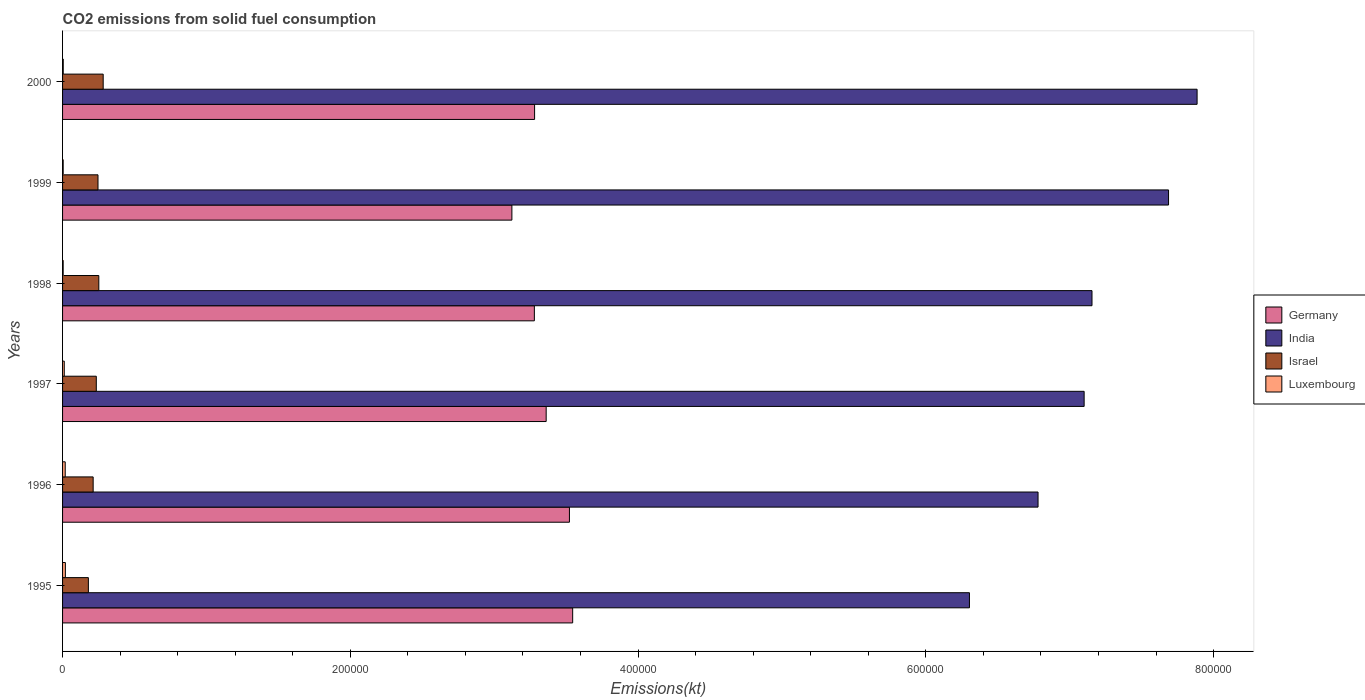How many different coloured bars are there?
Your response must be concise. 4. How many groups of bars are there?
Your answer should be compact. 6. Are the number of bars per tick equal to the number of legend labels?
Provide a succinct answer. Yes. What is the amount of CO2 emitted in India in 1996?
Provide a succinct answer. 6.78e+05. Across all years, what is the maximum amount of CO2 emitted in Luxembourg?
Your answer should be very brief. 1947.18. Across all years, what is the minimum amount of CO2 emitted in India?
Ensure brevity in your answer.  6.30e+05. In which year was the amount of CO2 emitted in India maximum?
Offer a terse response. 2000. In which year was the amount of CO2 emitted in Germany minimum?
Your response must be concise. 1999. What is the total amount of CO2 emitted in Germany in the graph?
Provide a succinct answer. 2.01e+06. What is the difference between the amount of CO2 emitted in Germany in 1995 and that in 1998?
Offer a terse response. 2.66e+04. What is the difference between the amount of CO2 emitted in Luxembourg in 2000 and the amount of CO2 emitted in Germany in 1995?
Your answer should be compact. -3.54e+05. What is the average amount of CO2 emitted in Germany per year?
Keep it short and to the point. 3.35e+05. In the year 1995, what is the difference between the amount of CO2 emitted in India and amount of CO2 emitted in Luxembourg?
Your answer should be very brief. 6.28e+05. In how many years, is the amount of CO2 emitted in India greater than 40000 kt?
Ensure brevity in your answer.  6. What is the ratio of the amount of CO2 emitted in Israel in 1996 to that in 2000?
Offer a very short reply. 0.75. Is the amount of CO2 emitted in Germany in 1999 less than that in 2000?
Your answer should be compact. Yes. Is the difference between the amount of CO2 emitted in India in 1997 and 1998 greater than the difference between the amount of CO2 emitted in Luxembourg in 1997 and 1998?
Provide a short and direct response. No. What is the difference between the highest and the second highest amount of CO2 emitted in India?
Ensure brevity in your answer.  1.98e+04. What is the difference between the highest and the lowest amount of CO2 emitted in Israel?
Provide a succinct answer. 1.03e+04. In how many years, is the amount of CO2 emitted in Luxembourg greater than the average amount of CO2 emitted in Luxembourg taken over all years?
Offer a very short reply. 3. Is it the case that in every year, the sum of the amount of CO2 emitted in Israel and amount of CO2 emitted in India is greater than the sum of amount of CO2 emitted in Luxembourg and amount of CO2 emitted in Germany?
Your answer should be very brief. Yes. What does the 3rd bar from the top in 1995 represents?
Ensure brevity in your answer.  India. Are all the bars in the graph horizontal?
Your response must be concise. Yes. How many years are there in the graph?
Keep it short and to the point. 6. What is the difference between two consecutive major ticks on the X-axis?
Provide a succinct answer. 2.00e+05. Does the graph contain any zero values?
Your answer should be very brief. No. Does the graph contain grids?
Ensure brevity in your answer.  No. How many legend labels are there?
Give a very brief answer. 4. What is the title of the graph?
Keep it short and to the point. CO2 emissions from solid fuel consumption. Does "Georgia" appear as one of the legend labels in the graph?
Your answer should be compact. No. What is the label or title of the X-axis?
Keep it short and to the point. Emissions(kt). What is the label or title of the Y-axis?
Your response must be concise. Years. What is the Emissions(kt) of Germany in 1995?
Your response must be concise. 3.55e+05. What is the Emissions(kt) in India in 1995?
Your response must be concise. 6.30e+05. What is the Emissions(kt) of Israel in 1995?
Make the answer very short. 1.79e+04. What is the Emissions(kt) in Luxembourg in 1995?
Make the answer very short. 1947.18. What is the Emissions(kt) in Germany in 1996?
Provide a short and direct response. 3.52e+05. What is the Emissions(kt) in India in 1996?
Your answer should be very brief. 6.78e+05. What is the Emissions(kt) of Israel in 1996?
Give a very brief answer. 2.13e+04. What is the Emissions(kt) of Luxembourg in 1996?
Offer a terse response. 1840.83. What is the Emissions(kt) of Germany in 1997?
Your response must be concise. 3.36e+05. What is the Emissions(kt) of India in 1997?
Your answer should be compact. 7.10e+05. What is the Emissions(kt) of Israel in 1997?
Ensure brevity in your answer.  2.34e+04. What is the Emissions(kt) of Luxembourg in 1997?
Offer a very short reply. 1184.44. What is the Emissions(kt) of Germany in 1998?
Offer a terse response. 3.28e+05. What is the Emissions(kt) in India in 1998?
Provide a succinct answer. 7.15e+05. What is the Emissions(kt) of Israel in 1998?
Your answer should be compact. 2.52e+04. What is the Emissions(kt) in Luxembourg in 1998?
Provide a short and direct response. 425.37. What is the Emissions(kt) of Germany in 1999?
Provide a succinct answer. 3.12e+05. What is the Emissions(kt) of India in 1999?
Keep it short and to the point. 7.69e+05. What is the Emissions(kt) of Israel in 1999?
Your answer should be very brief. 2.46e+04. What is the Emissions(kt) of Luxembourg in 1999?
Keep it short and to the point. 429.04. What is the Emissions(kt) in Germany in 2000?
Ensure brevity in your answer.  3.28e+05. What is the Emissions(kt) of India in 2000?
Your answer should be compact. 7.89e+05. What is the Emissions(kt) of Israel in 2000?
Your response must be concise. 2.82e+04. What is the Emissions(kt) of Luxembourg in 2000?
Offer a very short reply. 476.71. Across all years, what is the maximum Emissions(kt) of Germany?
Your answer should be very brief. 3.55e+05. Across all years, what is the maximum Emissions(kt) of India?
Offer a terse response. 7.89e+05. Across all years, what is the maximum Emissions(kt) in Israel?
Your answer should be very brief. 2.82e+04. Across all years, what is the maximum Emissions(kt) of Luxembourg?
Keep it short and to the point. 1947.18. Across all years, what is the minimum Emissions(kt) in Germany?
Give a very brief answer. 3.12e+05. Across all years, what is the minimum Emissions(kt) of India?
Offer a very short reply. 6.30e+05. Across all years, what is the minimum Emissions(kt) of Israel?
Your answer should be compact. 1.79e+04. Across all years, what is the minimum Emissions(kt) of Luxembourg?
Ensure brevity in your answer.  425.37. What is the total Emissions(kt) in Germany in the graph?
Give a very brief answer. 2.01e+06. What is the total Emissions(kt) in India in the graph?
Offer a very short reply. 4.29e+06. What is the total Emissions(kt) in Israel in the graph?
Provide a short and direct response. 1.41e+05. What is the total Emissions(kt) in Luxembourg in the graph?
Your answer should be very brief. 6303.57. What is the difference between the Emissions(kt) of Germany in 1995 and that in 1996?
Your response must be concise. 2244.2. What is the difference between the Emissions(kt) of India in 1995 and that in 1996?
Provide a short and direct response. -4.77e+04. What is the difference between the Emissions(kt) of Israel in 1995 and that in 1996?
Give a very brief answer. -3322.3. What is the difference between the Emissions(kt) in Luxembourg in 1995 and that in 1996?
Offer a very short reply. 106.34. What is the difference between the Emissions(kt) of Germany in 1995 and that in 1997?
Provide a short and direct response. 1.84e+04. What is the difference between the Emissions(kt) in India in 1995 and that in 1997?
Provide a short and direct response. -7.97e+04. What is the difference between the Emissions(kt) in Israel in 1995 and that in 1997?
Make the answer very short. -5504.17. What is the difference between the Emissions(kt) of Luxembourg in 1995 and that in 1997?
Ensure brevity in your answer.  762.74. What is the difference between the Emissions(kt) in Germany in 1995 and that in 1998?
Offer a terse response. 2.66e+04. What is the difference between the Emissions(kt) of India in 1995 and that in 1998?
Give a very brief answer. -8.52e+04. What is the difference between the Emissions(kt) of Israel in 1995 and that in 1998?
Ensure brevity in your answer.  -7249.66. What is the difference between the Emissions(kt) of Luxembourg in 1995 and that in 1998?
Provide a succinct answer. 1521.81. What is the difference between the Emissions(kt) in Germany in 1995 and that in 1999?
Ensure brevity in your answer.  4.22e+04. What is the difference between the Emissions(kt) in India in 1995 and that in 1999?
Provide a succinct answer. -1.38e+05. What is the difference between the Emissions(kt) in Israel in 1995 and that in 1999?
Your response must be concise. -6684.94. What is the difference between the Emissions(kt) of Luxembourg in 1995 and that in 1999?
Ensure brevity in your answer.  1518.14. What is the difference between the Emissions(kt) in Germany in 1995 and that in 2000?
Your answer should be compact. 2.65e+04. What is the difference between the Emissions(kt) in India in 1995 and that in 2000?
Your response must be concise. -1.58e+05. What is the difference between the Emissions(kt) in Israel in 1995 and that in 2000?
Your answer should be very brief. -1.03e+04. What is the difference between the Emissions(kt) in Luxembourg in 1995 and that in 2000?
Offer a very short reply. 1470.47. What is the difference between the Emissions(kt) of Germany in 1996 and that in 1997?
Make the answer very short. 1.62e+04. What is the difference between the Emissions(kt) in India in 1996 and that in 1997?
Offer a very short reply. -3.20e+04. What is the difference between the Emissions(kt) in Israel in 1996 and that in 1997?
Give a very brief answer. -2181.86. What is the difference between the Emissions(kt) in Luxembourg in 1996 and that in 1997?
Your answer should be very brief. 656.39. What is the difference between the Emissions(kt) in Germany in 1996 and that in 1998?
Offer a very short reply. 2.44e+04. What is the difference between the Emissions(kt) in India in 1996 and that in 1998?
Provide a succinct answer. -3.75e+04. What is the difference between the Emissions(kt) of Israel in 1996 and that in 1998?
Make the answer very short. -3927.36. What is the difference between the Emissions(kt) in Luxembourg in 1996 and that in 1998?
Provide a short and direct response. 1415.46. What is the difference between the Emissions(kt) of Germany in 1996 and that in 1999?
Ensure brevity in your answer.  4.00e+04. What is the difference between the Emissions(kt) of India in 1996 and that in 1999?
Provide a succinct answer. -9.07e+04. What is the difference between the Emissions(kt) in Israel in 1996 and that in 1999?
Your answer should be compact. -3362.64. What is the difference between the Emissions(kt) of Luxembourg in 1996 and that in 1999?
Give a very brief answer. 1411.8. What is the difference between the Emissions(kt) in Germany in 1996 and that in 2000?
Make the answer very short. 2.42e+04. What is the difference between the Emissions(kt) of India in 1996 and that in 2000?
Your response must be concise. -1.11e+05. What is the difference between the Emissions(kt) of Israel in 1996 and that in 2000?
Provide a succinct answer. -6967.3. What is the difference between the Emissions(kt) in Luxembourg in 1996 and that in 2000?
Keep it short and to the point. 1364.12. What is the difference between the Emissions(kt) in Germany in 1997 and that in 1998?
Your response must be concise. 8206.75. What is the difference between the Emissions(kt) of India in 1997 and that in 1998?
Offer a terse response. -5460.16. What is the difference between the Emissions(kt) of Israel in 1997 and that in 1998?
Your answer should be very brief. -1745.49. What is the difference between the Emissions(kt) of Luxembourg in 1997 and that in 1998?
Your answer should be very brief. 759.07. What is the difference between the Emissions(kt) in Germany in 1997 and that in 1999?
Your response must be concise. 2.38e+04. What is the difference between the Emissions(kt) in India in 1997 and that in 1999?
Your answer should be compact. -5.87e+04. What is the difference between the Emissions(kt) in Israel in 1997 and that in 1999?
Provide a short and direct response. -1180.77. What is the difference between the Emissions(kt) of Luxembourg in 1997 and that in 1999?
Ensure brevity in your answer.  755.4. What is the difference between the Emissions(kt) in Germany in 1997 and that in 2000?
Make the answer very short. 8049.06. What is the difference between the Emissions(kt) of India in 1997 and that in 2000?
Ensure brevity in your answer.  -7.85e+04. What is the difference between the Emissions(kt) of Israel in 1997 and that in 2000?
Provide a succinct answer. -4785.44. What is the difference between the Emissions(kt) in Luxembourg in 1997 and that in 2000?
Your answer should be very brief. 707.73. What is the difference between the Emissions(kt) in Germany in 1998 and that in 1999?
Make the answer very short. 1.56e+04. What is the difference between the Emissions(kt) of India in 1998 and that in 1999?
Ensure brevity in your answer.  -5.32e+04. What is the difference between the Emissions(kt) in Israel in 1998 and that in 1999?
Provide a short and direct response. 564.72. What is the difference between the Emissions(kt) in Luxembourg in 1998 and that in 1999?
Offer a very short reply. -3.67. What is the difference between the Emissions(kt) of Germany in 1998 and that in 2000?
Keep it short and to the point. -157.68. What is the difference between the Emissions(kt) of India in 1998 and that in 2000?
Ensure brevity in your answer.  -7.30e+04. What is the difference between the Emissions(kt) in Israel in 1998 and that in 2000?
Your response must be concise. -3039.94. What is the difference between the Emissions(kt) of Luxembourg in 1998 and that in 2000?
Your response must be concise. -51.34. What is the difference between the Emissions(kt) in Germany in 1999 and that in 2000?
Provide a short and direct response. -1.58e+04. What is the difference between the Emissions(kt) in India in 1999 and that in 2000?
Give a very brief answer. -1.98e+04. What is the difference between the Emissions(kt) of Israel in 1999 and that in 2000?
Make the answer very short. -3604.66. What is the difference between the Emissions(kt) of Luxembourg in 1999 and that in 2000?
Your answer should be compact. -47.67. What is the difference between the Emissions(kt) of Germany in 1995 and the Emissions(kt) of India in 1996?
Your response must be concise. -3.23e+05. What is the difference between the Emissions(kt) in Germany in 1995 and the Emissions(kt) in Israel in 1996?
Provide a short and direct response. 3.33e+05. What is the difference between the Emissions(kt) of Germany in 1995 and the Emissions(kt) of Luxembourg in 1996?
Your answer should be very brief. 3.53e+05. What is the difference between the Emissions(kt) of India in 1995 and the Emissions(kt) of Israel in 1996?
Keep it short and to the point. 6.09e+05. What is the difference between the Emissions(kt) of India in 1995 and the Emissions(kt) of Luxembourg in 1996?
Provide a succinct answer. 6.28e+05. What is the difference between the Emissions(kt) of Israel in 1995 and the Emissions(kt) of Luxembourg in 1996?
Your answer should be compact. 1.61e+04. What is the difference between the Emissions(kt) in Germany in 1995 and the Emissions(kt) in India in 1997?
Provide a short and direct response. -3.55e+05. What is the difference between the Emissions(kt) in Germany in 1995 and the Emissions(kt) in Israel in 1997?
Keep it short and to the point. 3.31e+05. What is the difference between the Emissions(kt) in Germany in 1995 and the Emissions(kt) in Luxembourg in 1997?
Provide a short and direct response. 3.53e+05. What is the difference between the Emissions(kt) of India in 1995 and the Emissions(kt) of Israel in 1997?
Ensure brevity in your answer.  6.07e+05. What is the difference between the Emissions(kt) of India in 1995 and the Emissions(kt) of Luxembourg in 1997?
Ensure brevity in your answer.  6.29e+05. What is the difference between the Emissions(kt) in Israel in 1995 and the Emissions(kt) in Luxembourg in 1997?
Offer a terse response. 1.68e+04. What is the difference between the Emissions(kt) in Germany in 1995 and the Emissions(kt) in India in 1998?
Ensure brevity in your answer.  -3.61e+05. What is the difference between the Emissions(kt) of Germany in 1995 and the Emissions(kt) of Israel in 1998?
Your response must be concise. 3.29e+05. What is the difference between the Emissions(kt) of Germany in 1995 and the Emissions(kt) of Luxembourg in 1998?
Offer a very short reply. 3.54e+05. What is the difference between the Emissions(kt) in India in 1995 and the Emissions(kt) in Israel in 1998?
Your response must be concise. 6.05e+05. What is the difference between the Emissions(kt) in India in 1995 and the Emissions(kt) in Luxembourg in 1998?
Your response must be concise. 6.30e+05. What is the difference between the Emissions(kt) in Israel in 1995 and the Emissions(kt) in Luxembourg in 1998?
Provide a short and direct response. 1.75e+04. What is the difference between the Emissions(kt) of Germany in 1995 and the Emissions(kt) of India in 1999?
Your answer should be very brief. -4.14e+05. What is the difference between the Emissions(kt) of Germany in 1995 and the Emissions(kt) of Israel in 1999?
Provide a succinct answer. 3.30e+05. What is the difference between the Emissions(kt) in Germany in 1995 and the Emissions(kt) in Luxembourg in 1999?
Your answer should be very brief. 3.54e+05. What is the difference between the Emissions(kt) of India in 1995 and the Emissions(kt) of Israel in 1999?
Keep it short and to the point. 6.06e+05. What is the difference between the Emissions(kt) in India in 1995 and the Emissions(kt) in Luxembourg in 1999?
Ensure brevity in your answer.  6.30e+05. What is the difference between the Emissions(kt) in Israel in 1995 and the Emissions(kt) in Luxembourg in 1999?
Provide a succinct answer. 1.75e+04. What is the difference between the Emissions(kt) in Germany in 1995 and the Emissions(kt) in India in 2000?
Keep it short and to the point. -4.34e+05. What is the difference between the Emissions(kt) in Germany in 1995 and the Emissions(kt) in Israel in 2000?
Your response must be concise. 3.26e+05. What is the difference between the Emissions(kt) of Germany in 1995 and the Emissions(kt) of Luxembourg in 2000?
Your answer should be very brief. 3.54e+05. What is the difference between the Emissions(kt) in India in 1995 and the Emissions(kt) in Israel in 2000?
Make the answer very short. 6.02e+05. What is the difference between the Emissions(kt) in India in 1995 and the Emissions(kt) in Luxembourg in 2000?
Offer a terse response. 6.30e+05. What is the difference between the Emissions(kt) of Israel in 1995 and the Emissions(kt) of Luxembourg in 2000?
Your answer should be very brief. 1.75e+04. What is the difference between the Emissions(kt) in Germany in 1996 and the Emissions(kt) in India in 1997?
Offer a very short reply. -3.58e+05. What is the difference between the Emissions(kt) of Germany in 1996 and the Emissions(kt) of Israel in 1997?
Your answer should be compact. 3.29e+05. What is the difference between the Emissions(kt) in Germany in 1996 and the Emissions(kt) in Luxembourg in 1997?
Ensure brevity in your answer.  3.51e+05. What is the difference between the Emissions(kt) of India in 1996 and the Emissions(kt) of Israel in 1997?
Offer a very short reply. 6.55e+05. What is the difference between the Emissions(kt) of India in 1996 and the Emissions(kt) of Luxembourg in 1997?
Your answer should be compact. 6.77e+05. What is the difference between the Emissions(kt) in Israel in 1996 and the Emissions(kt) in Luxembourg in 1997?
Give a very brief answer. 2.01e+04. What is the difference between the Emissions(kt) in Germany in 1996 and the Emissions(kt) in India in 1998?
Provide a succinct answer. -3.63e+05. What is the difference between the Emissions(kt) of Germany in 1996 and the Emissions(kt) of Israel in 1998?
Offer a very short reply. 3.27e+05. What is the difference between the Emissions(kt) of Germany in 1996 and the Emissions(kt) of Luxembourg in 1998?
Make the answer very short. 3.52e+05. What is the difference between the Emissions(kt) of India in 1996 and the Emissions(kt) of Israel in 1998?
Offer a very short reply. 6.53e+05. What is the difference between the Emissions(kt) in India in 1996 and the Emissions(kt) in Luxembourg in 1998?
Ensure brevity in your answer.  6.78e+05. What is the difference between the Emissions(kt) of Israel in 1996 and the Emissions(kt) of Luxembourg in 1998?
Make the answer very short. 2.08e+04. What is the difference between the Emissions(kt) in Germany in 1996 and the Emissions(kt) in India in 1999?
Your response must be concise. -4.16e+05. What is the difference between the Emissions(kt) in Germany in 1996 and the Emissions(kt) in Israel in 1999?
Offer a terse response. 3.28e+05. What is the difference between the Emissions(kt) in Germany in 1996 and the Emissions(kt) in Luxembourg in 1999?
Offer a terse response. 3.52e+05. What is the difference between the Emissions(kt) of India in 1996 and the Emissions(kt) of Israel in 1999?
Your answer should be compact. 6.53e+05. What is the difference between the Emissions(kt) of India in 1996 and the Emissions(kt) of Luxembourg in 1999?
Keep it short and to the point. 6.78e+05. What is the difference between the Emissions(kt) of Israel in 1996 and the Emissions(kt) of Luxembourg in 1999?
Keep it short and to the point. 2.08e+04. What is the difference between the Emissions(kt) in Germany in 1996 and the Emissions(kt) in India in 2000?
Your answer should be very brief. -4.36e+05. What is the difference between the Emissions(kt) in Germany in 1996 and the Emissions(kt) in Israel in 2000?
Your response must be concise. 3.24e+05. What is the difference between the Emissions(kt) of Germany in 1996 and the Emissions(kt) of Luxembourg in 2000?
Keep it short and to the point. 3.52e+05. What is the difference between the Emissions(kt) in India in 1996 and the Emissions(kt) in Israel in 2000?
Offer a very short reply. 6.50e+05. What is the difference between the Emissions(kt) of India in 1996 and the Emissions(kt) of Luxembourg in 2000?
Offer a very short reply. 6.77e+05. What is the difference between the Emissions(kt) in Israel in 1996 and the Emissions(kt) in Luxembourg in 2000?
Provide a short and direct response. 2.08e+04. What is the difference between the Emissions(kt) in Germany in 1997 and the Emissions(kt) in India in 1998?
Your answer should be compact. -3.79e+05. What is the difference between the Emissions(kt) in Germany in 1997 and the Emissions(kt) in Israel in 1998?
Give a very brief answer. 3.11e+05. What is the difference between the Emissions(kt) of Germany in 1997 and the Emissions(kt) of Luxembourg in 1998?
Your answer should be very brief. 3.36e+05. What is the difference between the Emissions(kt) in India in 1997 and the Emissions(kt) in Israel in 1998?
Give a very brief answer. 6.85e+05. What is the difference between the Emissions(kt) in India in 1997 and the Emissions(kt) in Luxembourg in 1998?
Provide a succinct answer. 7.10e+05. What is the difference between the Emissions(kt) in Israel in 1997 and the Emissions(kt) in Luxembourg in 1998?
Your answer should be compact. 2.30e+04. What is the difference between the Emissions(kt) of Germany in 1997 and the Emissions(kt) of India in 1999?
Keep it short and to the point. -4.33e+05. What is the difference between the Emissions(kt) of Germany in 1997 and the Emissions(kt) of Israel in 1999?
Your answer should be compact. 3.11e+05. What is the difference between the Emissions(kt) in Germany in 1997 and the Emissions(kt) in Luxembourg in 1999?
Your answer should be very brief. 3.36e+05. What is the difference between the Emissions(kt) in India in 1997 and the Emissions(kt) in Israel in 1999?
Offer a terse response. 6.85e+05. What is the difference between the Emissions(kt) of India in 1997 and the Emissions(kt) of Luxembourg in 1999?
Ensure brevity in your answer.  7.10e+05. What is the difference between the Emissions(kt) of Israel in 1997 and the Emissions(kt) of Luxembourg in 1999?
Your answer should be very brief. 2.30e+04. What is the difference between the Emissions(kt) in Germany in 1997 and the Emissions(kt) in India in 2000?
Offer a terse response. -4.52e+05. What is the difference between the Emissions(kt) of Germany in 1997 and the Emissions(kt) of Israel in 2000?
Offer a very short reply. 3.08e+05. What is the difference between the Emissions(kt) in Germany in 1997 and the Emissions(kt) in Luxembourg in 2000?
Your answer should be compact. 3.36e+05. What is the difference between the Emissions(kt) of India in 1997 and the Emissions(kt) of Israel in 2000?
Offer a very short reply. 6.82e+05. What is the difference between the Emissions(kt) of India in 1997 and the Emissions(kt) of Luxembourg in 2000?
Provide a short and direct response. 7.10e+05. What is the difference between the Emissions(kt) in Israel in 1997 and the Emissions(kt) in Luxembourg in 2000?
Ensure brevity in your answer.  2.30e+04. What is the difference between the Emissions(kt) in Germany in 1998 and the Emissions(kt) in India in 1999?
Keep it short and to the point. -4.41e+05. What is the difference between the Emissions(kt) of Germany in 1998 and the Emissions(kt) of Israel in 1999?
Ensure brevity in your answer.  3.03e+05. What is the difference between the Emissions(kt) in Germany in 1998 and the Emissions(kt) in Luxembourg in 1999?
Your answer should be compact. 3.27e+05. What is the difference between the Emissions(kt) of India in 1998 and the Emissions(kt) of Israel in 1999?
Provide a short and direct response. 6.91e+05. What is the difference between the Emissions(kt) of India in 1998 and the Emissions(kt) of Luxembourg in 1999?
Offer a very short reply. 7.15e+05. What is the difference between the Emissions(kt) in Israel in 1998 and the Emissions(kt) in Luxembourg in 1999?
Offer a terse response. 2.48e+04. What is the difference between the Emissions(kt) of Germany in 1998 and the Emissions(kt) of India in 2000?
Provide a succinct answer. -4.61e+05. What is the difference between the Emissions(kt) of Germany in 1998 and the Emissions(kt) of Israel in 2000?
Give a very brief answer. 3.00e+05. What is the difference between the Emissions(kt) of Germany in 1998 and the Emissions(kt) of Luxembourg in 2000?
Keep it short and to the point. 3.27e+05. What is the difference between the Emissions(kt) of India in 1998 and the Emissions(kt) of Israel in 2000?
Provide a short and direct response. 6.87e+05. What is the difference between the Emissions(kt) of India in 1998 and the Emissions(kt) of Luxembourg in 2000?
Your answer should be compact. 7.15e+05. What is the difference between the Emissions(kt) of Israel in 1998 and the Emissions(kt) of Luxembourg in 2000?
Keep it short and to the point. 2.47e+04. What is the difference between the Emissions(kt) of Germany in 1999 and the Emissions(kt) of India in 2000?
Keep it short and to the point. -4.76e+05. What is the difference between the Emissions(kt) in Germany in 1999 and the Emissions(kt) in Israel in 2000?
Your answer should be compact. 2.84e+05. What is the difference between the Emissions(kt) of Germany in 1999 and the Emissions(kt) of Luxembourg in 2000?
Make the answer very short. 3.12e+05. What is the difference between the Emissions(kt) in India in 1999 and the Emissions(kt) in Israel in 2000?
Provide a short and direct response. 7.40e+05. What is the difference between the Emissions(kt) in India in 1999 and the Emissions(kt) in Luxembourg in 2000?
Provide a short and direct response. 7.68e+05. What is the difference between the Emissions(kt) of Israel in 1999 and the Emissions(kt) of Luxembourg in 2000?
Give a very brief answer. 2.41e+04. What is the average Emissions(kt) in Germany per year?
Provide a succinct answer. 3.35e+05. What is the average Emissions(kt) in India per year?
Ensure brevity in your answer.  7.15e+05. What is the average Emissions(kt) in Israel per year?
Give a very brief answer. 2.34e+04. What is the average Emissions(kt) of Luxembourg per year?
Provide a succinct answer. 1050.6. In the year 1995, what is the difference between the Emissions(kt) in Germany and Emissions(kt) in India?
Keep it short and to the point. -2.76e+05. In the year 1995, what is the difference between the Emissions(kt) in Germany and Emissions(kt) in Israel?
Your answer should be very brief. 3.37e+05. In the year 1995, what is the difference between the Emissions(kt) in Germany and Emissions(kt) in Luxembourg?
Give a very brief answer. 3.53e+05. In the year 1995, what is the difference between the Emissions(kt) of India and Emissions(kt) of Israel?
Give a very brief answer. 6.12e+05. In the year 1995, what is the difference between the Emissions(kt) of India and Emissions(kt) of Luxembourg?
Your answer should be very brief. 6.28e+05. In the year 1995, what is the difference between the Emissions(kt) in Israel and Emissions(kt) in Luxembourg?
Keep it short and to the point. 1.60e+04. In the year 1996, what is the difference between the Emissions(kt) of Germany and Emissions(kt) of India?
Your answer should be compact. -3.26e+05. In the year 1996, what is the difference between the Emissions(kt) of Germany and Emissions(kt) of Israel?
Your response must be concise. 3.31e+05. In the year 1996, what is the difference between the Emissions(kt) of Germany and Emissions(kt) of Luxembourg?
Ensure brevity in your answer.  3.50e+05. In the year 1996, what is the difference between the Emissions(kt) in India and Emissions(kt) in Israel?
Ensure brevity in your answer.  6.57e+05. In the year 1996, what is the difference between the Emissions(kt) in India and Emissions(kt) in Luxembourg?
Ensure brevity in your answer.  6.76e+05. In the year 1996, what is the difference between the Emissions(kt) of Israel and Emissions(kt) of Luxembourg?
Provide a short and direct response. 1.94e+04. In the year 1997, what is the difference between the Emissions(kt) in Germany and Emissions(kt) in India?
Make the answer very short. -3.74e+05. In the year 1997, what is the difference between the Emissions(kt) in Germany and Emissions(kt) in Israel?
Provide a succinct answer. 3.13e+05. In the year 1997, what is the difference between the Emissions(kt) of Germany and Emissions(kt) of Luxembourg?
Your response must be concise. 3.35e+05. In the year 1997, what is the difference between the Emissions(kt) of India and Emissions(kt) of Israel?
Offer a very short reply. 6.87e+05. In the year 1997, what is the difference between the Emissions(kt) of India and Emissions(kt) of Luxembourg?
Give a very brief answer. 7.09e+05. In the year 1997, what is the difference between the Emissions(kt) in Israel and Emissions(kt) in Luxembourg?
Make the answer very short. 2.23e+04. In the year 1998, what is the difference between the Emissions(kt) of Germany and Emissions(kt) of India?
Ensure brevity in your answer.  -3.88e+05. In the year 1998, what is the difference between the Emissions(kt) of Germany and Emissions(kt) of Israel?
Your answer should be compact. 3.03e+05. In the year 1998, what is the difference between the Emissions(kt) in Germany and Emissions(kt) in Luxembourg?
Provide a short and direct response. 3.27e+05. In the year 1998, what is the difference between the Emissions(kt) of India and Emissions(kt) of Israel?
Ensure brevity in your answer.  6.90e+05. In the year 1998, what is the difference between the Emissions(kt) of India and Emissions(kt) of Luxembourg?
Offer a terse response. 7.15e+05. In the year 1998, what is the difference between the Emissions(kt) of Israel and Emissions(kt) of Luxembourg?
Your response must be concise. 2.48e+04. In the year 1999, what is the difference between the Emissions(kt) in Germany and Emissions(kt) in India?
Provide a short and direct response. -4.56e+05. In the year 1999, what is the difference between the Emissions(kt) in Germany and Emissions(kt) in Israel?
Give a very brief answer. 2.88e+05. In the year 1999, what is the difference between the Emissions(kt) of Germany and Emissions(kt) of Luxembourg?
Your answer should be very brief. 3.12e+05. In the year 1999, what is the difference between the Emissions(kt) of India and Emissions(kt) of Israel?
Provide a short and direct response. 7.44e+05. In the year 1999, what is the difference between the Emissions(kt) in India and Emissions(kt) in Luxembourg?
Offer a terse response. 7.68e+05. In the year 1999, what is the difference between the Emissions(kt) in Israel and Emissions(kt) in Luxembourg?
Offer a terse response. 2.42e+04. In the year 2000, what is the difference between the Emissions(kt) of Germany and Emissions(kt) of India?
Your response must be concise. -4.60e+05. In the year 2000, what is the difference between the Emissions(kt) in Germany and Emissions(kt) in Israel?
Offer a very short reply. 3.00e+05. In the year 2000, what is the difference between the Emissions(kt) in Germany and Emissions(kt) in Luxembourg?
Offer a very short reply. 3.28e+05. In the year 2000, what is the difference between the Emissions(kt) in India and Emissions(kt) in Israel?
Your response must be concise. 7.60e+05. In the year 2000, what is the difference between the Emissions(kt) in India and Emissions(kt) in Luxembourg?
Offer a very short reply. 7.88e+05. In the year 2000, what is the difference between the Emissions(kt) of Israel and Emissions(kt) of Luxembourg?
Ensure brevity in your answer.  2.78e+04. What is the ratio of the Emissions(kt) in Germany in 1995 to that in 1996?
Give a very brief answer. 1.01. What is the ratio of the Emissions(kt) in India in 1995 to that in 1996?
Give a very brief answer. 0.93. What is the ratio of the Emissions(kt) of Israel in 1995 to that in 1996?
Keep it short and to the point. 0.84. What is the ratio of the Emissions(kt) in Luxembourg in 1995 to that in 1996?
Your answer should be very brief. 1.06. What is the ratio of the Emissions(kt) of Germany in 1995 to that in 1997?
Offer a very short reply. 1.05. What is the ratio of the Emissions(kt) of India in 1995 to that in 1997?
Offer a terse response. 0.89. What is the ratio of the Emissions(kt) of Israel in 1995 to that in 1997?
Ensure brevity in your answer.  0.77. What is the ratio of the Emissions(kt) in Luxembourg in 1995 to that in 1997?
Offer a very short reply. 1.64. What is the ratio of the Emissions(kt) of Germany in 1995 to that in 1998?
Provide a succinct answer. 1.08. What is the ratio of the Emissions(kt) of India in 1995 to that in 1998?
Make the answer very short. 0.88. What is the ratio of the Emissions(kt) of Israel in 1995 to that in 1998?
Offer a terse response. 0.71. What is the ratio of the Emissions(kt) of Luxembourg in 1995 to that in 1998?
Your answer should be very brief. 4.58. What is the ratio of the Emissions(kt) in Germany in 1995 to that in 1999?
Ensure brevity in your answer.  1.14. What is the ratio of the Emissions(kt) in India in 1995 to that in 1999?
Provide a succinct answer. 0.82. What is the ratio of the Emissions(kt) in Israel in 1995 to that in 1999?
Provide a succinct answer. 0.73. What is the ratio of the Emissions(kt) of Luxembourg in 1995 to that in 1999?
Provide a succinct answer. 4.54. What is the ratio of the Emissions(kt) in Germany in 1995 to that in 2000?
Offer a terse response. 1.08. What is the ratio of the Emissions(kt) in India in 1995 to that in 2000?
Give a very brief answer. 0.8. What is the ratio of the Emissions(kt) in Israel in 1995 to that in 2000?
Provide a short and direct response. 0.64. What is the ratio of the Emissions(kt) of Luxembourg in 1995 to that in 2000?
Your response must be concise. 4.08. What is the ratio of the Emissions(kt) in Germany in 1996 to that in 1997?
Keep it short and to the point. 1.05. What is the ratio of the Emissions(kt) in India in 1996 to that in 1997?
Offer a terse response. 0.95. What is the ratio of the Emissions(kt) in Israel in 1996 to that in 1997?
Provide a succinct answer. 0.91. What is the ratio of the Emissions(kt) in Luxembourg in 1996 to that in 1997?
Your answer should be compact. 1.55. What is the ratio of the Emissions(kt) in Germany in 1996 to that in 1998?
Your answer should be compact. 1.07. What is the ratio of the Emissions(kt) of India in 1996 to that in 1998?
Your answer should be very brief. 0.95. What is the ratio of the Emissions(kt) in Israel in 1996 to that in 1998?
Offer a very short reply. 0.84. What is the ratio of the Emissions(kt) in Luxembourg in 1996 to that in 1998?
Give a very brief answer. 4.33. What is the ratio of the Emissions(kt) of Germany in 1996 to that in 1999?
Give a very brief answer. 1.13. What is the ratio of the Emissions(kt) in India in 1996 to that in 1999?
Your answer should be very brief. 0.88. What is the ratio of the Emissions(kt) of Israel in 1996 to that in 1999?
Give a very brief answer. 0.86. What is the ratio of the Emissions(kt) of Luxembourg in 1996 to that in 1999?
Keep it short and to the point. 4.29. What is the ratio of the Emissions(kt) of Germany in 1996 to that in 2000?
Provide a succinct answer. 1.07. What is the ratio of the Emissions(kt) of India in 1996 to that in 2000?
Your answer should be very brief. 0.86. What is the ratio of the Emissions(kt) of Israel in 1996 to that in 2000?
Give a very brief answer. 0.75. What is the ratio of the Emissions(kt) in Luxembourg in 1996 to that in 2000?
Provide a short and direct response. 3.86. What is the ratio of the Emissions(kt) in Israel in 1997 to that in 1998?
Your answer should be compact. 0.93. What is the ratio of the Emissions(kt) of Luxembourg in 1997 to that in 1998?
Offer a very short reply. 2.78. What is the ratio of the Emissions(kt) of Germany in 1997 to that in 1999?
Give a very brief answer. 1.08. What is the ratio of the Emissions(kt) of India in 1997 to that in 1999?
Your answer should be very brief. 0.92. What is the ratio of the Emissions(kt) of Israel in 1997 to that in 1999?
Offer a very short reply. 0.95. What is the ratio of the Emissions(kt) of Luxembourg in 1997 to that in 1999?
Your answer should be very brief. 2.76. What is the ratio of the Emissions(kt) of Germany in 1997 to that in 2000?
Your response must be concise. 1.02. What is the ratio of the Emissions(kt) in India in 1997 to that in 2000?
Keep it short and to the point. 0.9. What is the ratio of the Emissions(kt) of Israel in 1997 to that in 2000?
Offer a terse response. 0.83. What is the ratio of the Emissions(kt) of Luxembourg in 1997 to that in 2000?
Your answer should be very brief. 2.48. What is the ratio of the Emissions(kt) of Germany in 1998 to that in 1999?
Offer a terse response. 1.05. What is the ratio of the Emissions(kt) of India in 1998 to that in 1999?
Provide a succinct answer. 0.93. What is the ratio of the Emissions(kt) of Israel in 1998 to that in 1999?
Give a very brief answer. 1.02. What is the ratio of the Emissions(kt) of India in 1998 to that in 2000?
Make the answer very short. 0.91. What is the ratio of the Emissions(kt) in Israel in 1998 to that in 2000?
Your response must be concise. 0.89. What is the ratio of the Emissions(kt) of Luxembourg in 1998 to that in 2000?
Provide a short and direct response. 0.89. What is the ratio of the Emissions(kt) in Germany in 1999 to that in 2000?
Make the answer very short. 0.95. What is the ratio of the Emissions(kt) of India in 1999 to that in 2000?
Ensure brevity in your answer.  0.97. What is the ratio of the Emissions(kt) in Israel in 1999 to that in 2000?
Your response must be concise. 0.87. What is the difference between the highest and the second highest Emissions(kt) in Germany?
Keep it short and to the point. 2244.2. What is the difference between the highest and the second highest Emissions(kt) of India?
Make the answer very short. 1.98e+04. What is the difference between the highest and the second highest Emissions(kt) of Israel?
Your answer should be compact. 3039.94. What is the difference between the highest and the second highest Emissions(kt) in Luxembourg?
Your response must be concise. 106.34. What is the difference between the highest and the lowest Emissions(kt) of Germany?
Offer a terse response. 4.22e+04. What is the difference between the highest and the lowest Emissions(kt) in India?
Give a very brief answer. 1.58e+05. What is the difference between the highest and the lowest Emissions(kt) of Israel?
Provide a short and direct response. 1.03e+04. What is the difference between the highest and the lowest Emissions(kt) in Luxembourg?
Offer a very short reply. 1521.81. 